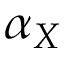<formula> <loc_0><loc_0><loc_500><loc_500>\alpha _ { X }</formula> 